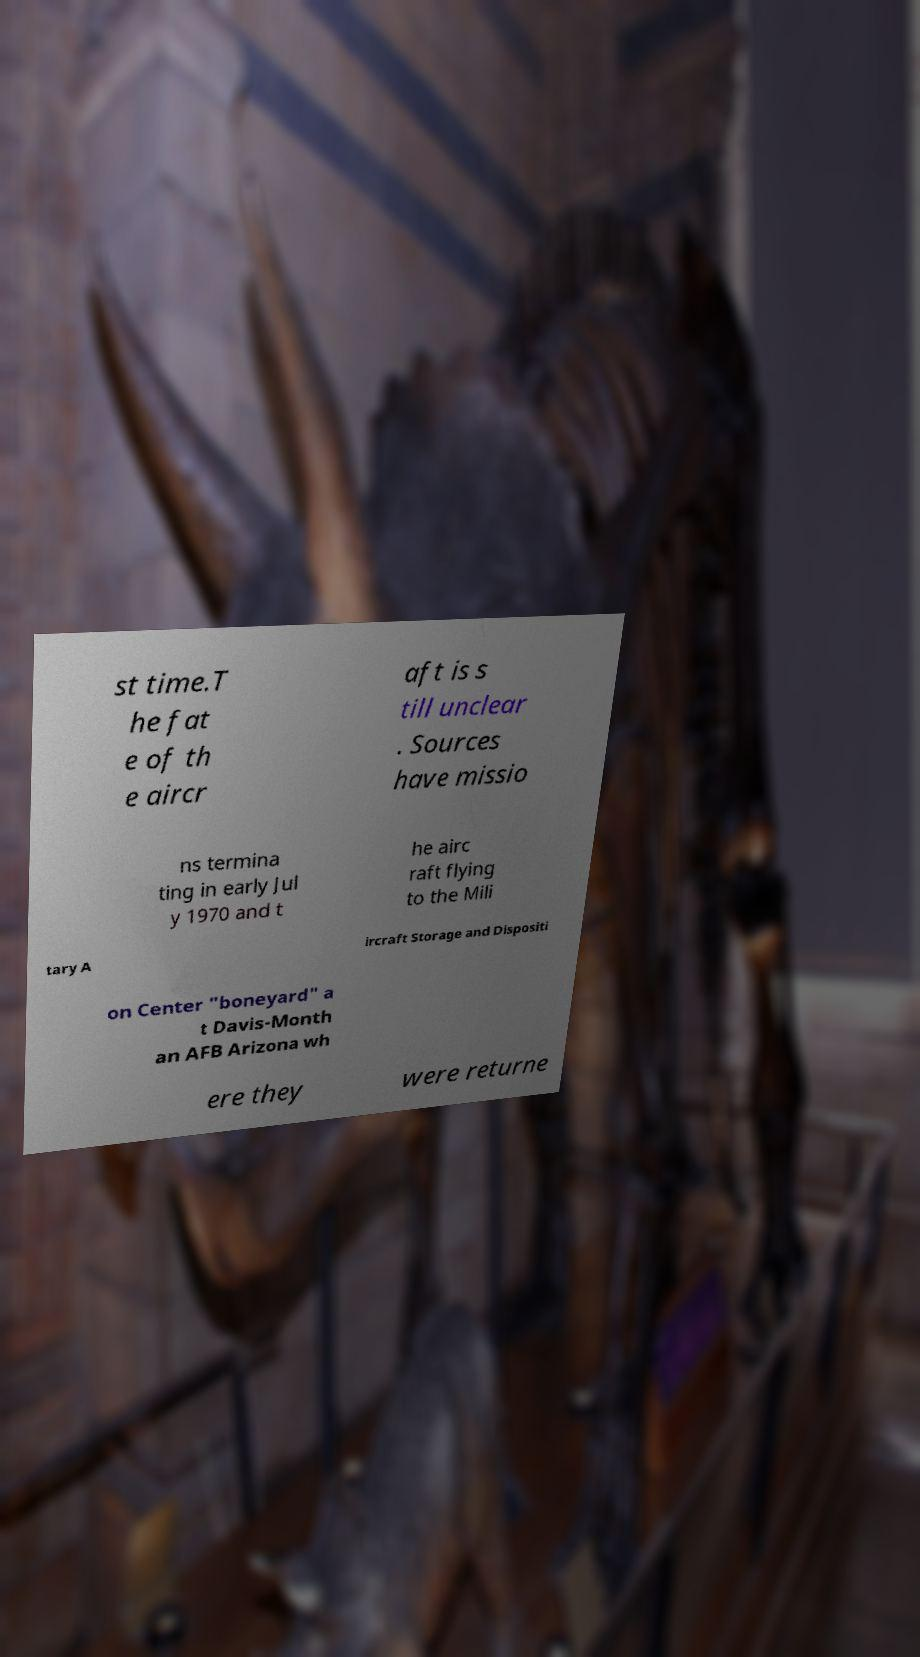What messages or text are displayed in this image? I need them in a readable, typed format. st time.T he fat e of th e aircr aft is s till unclear . Sources have missio ns termina ting in early Jul y 1970 and t he airc raft flying to the Mili tary A ircraft Storage and Dispositi on Center "boneyard" a t Davis-Month an AFB Arizona wh ere they were returne 